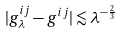Convert formula to latex. <formula><loc_0><loc_0><loc_500><loc_500>| g ^ { i j } _ { \lambda } - g ^ { i j } | \lesssim \lambda ^ { - \frac { 2 } { 3 } }</formula> 